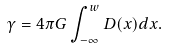<formula> <loc_0><loc_0><loc_500><loc_500>\gamma = 4 \pi G \int _ { - \infty } ^ { w } D ( x ) d x .</formula> 